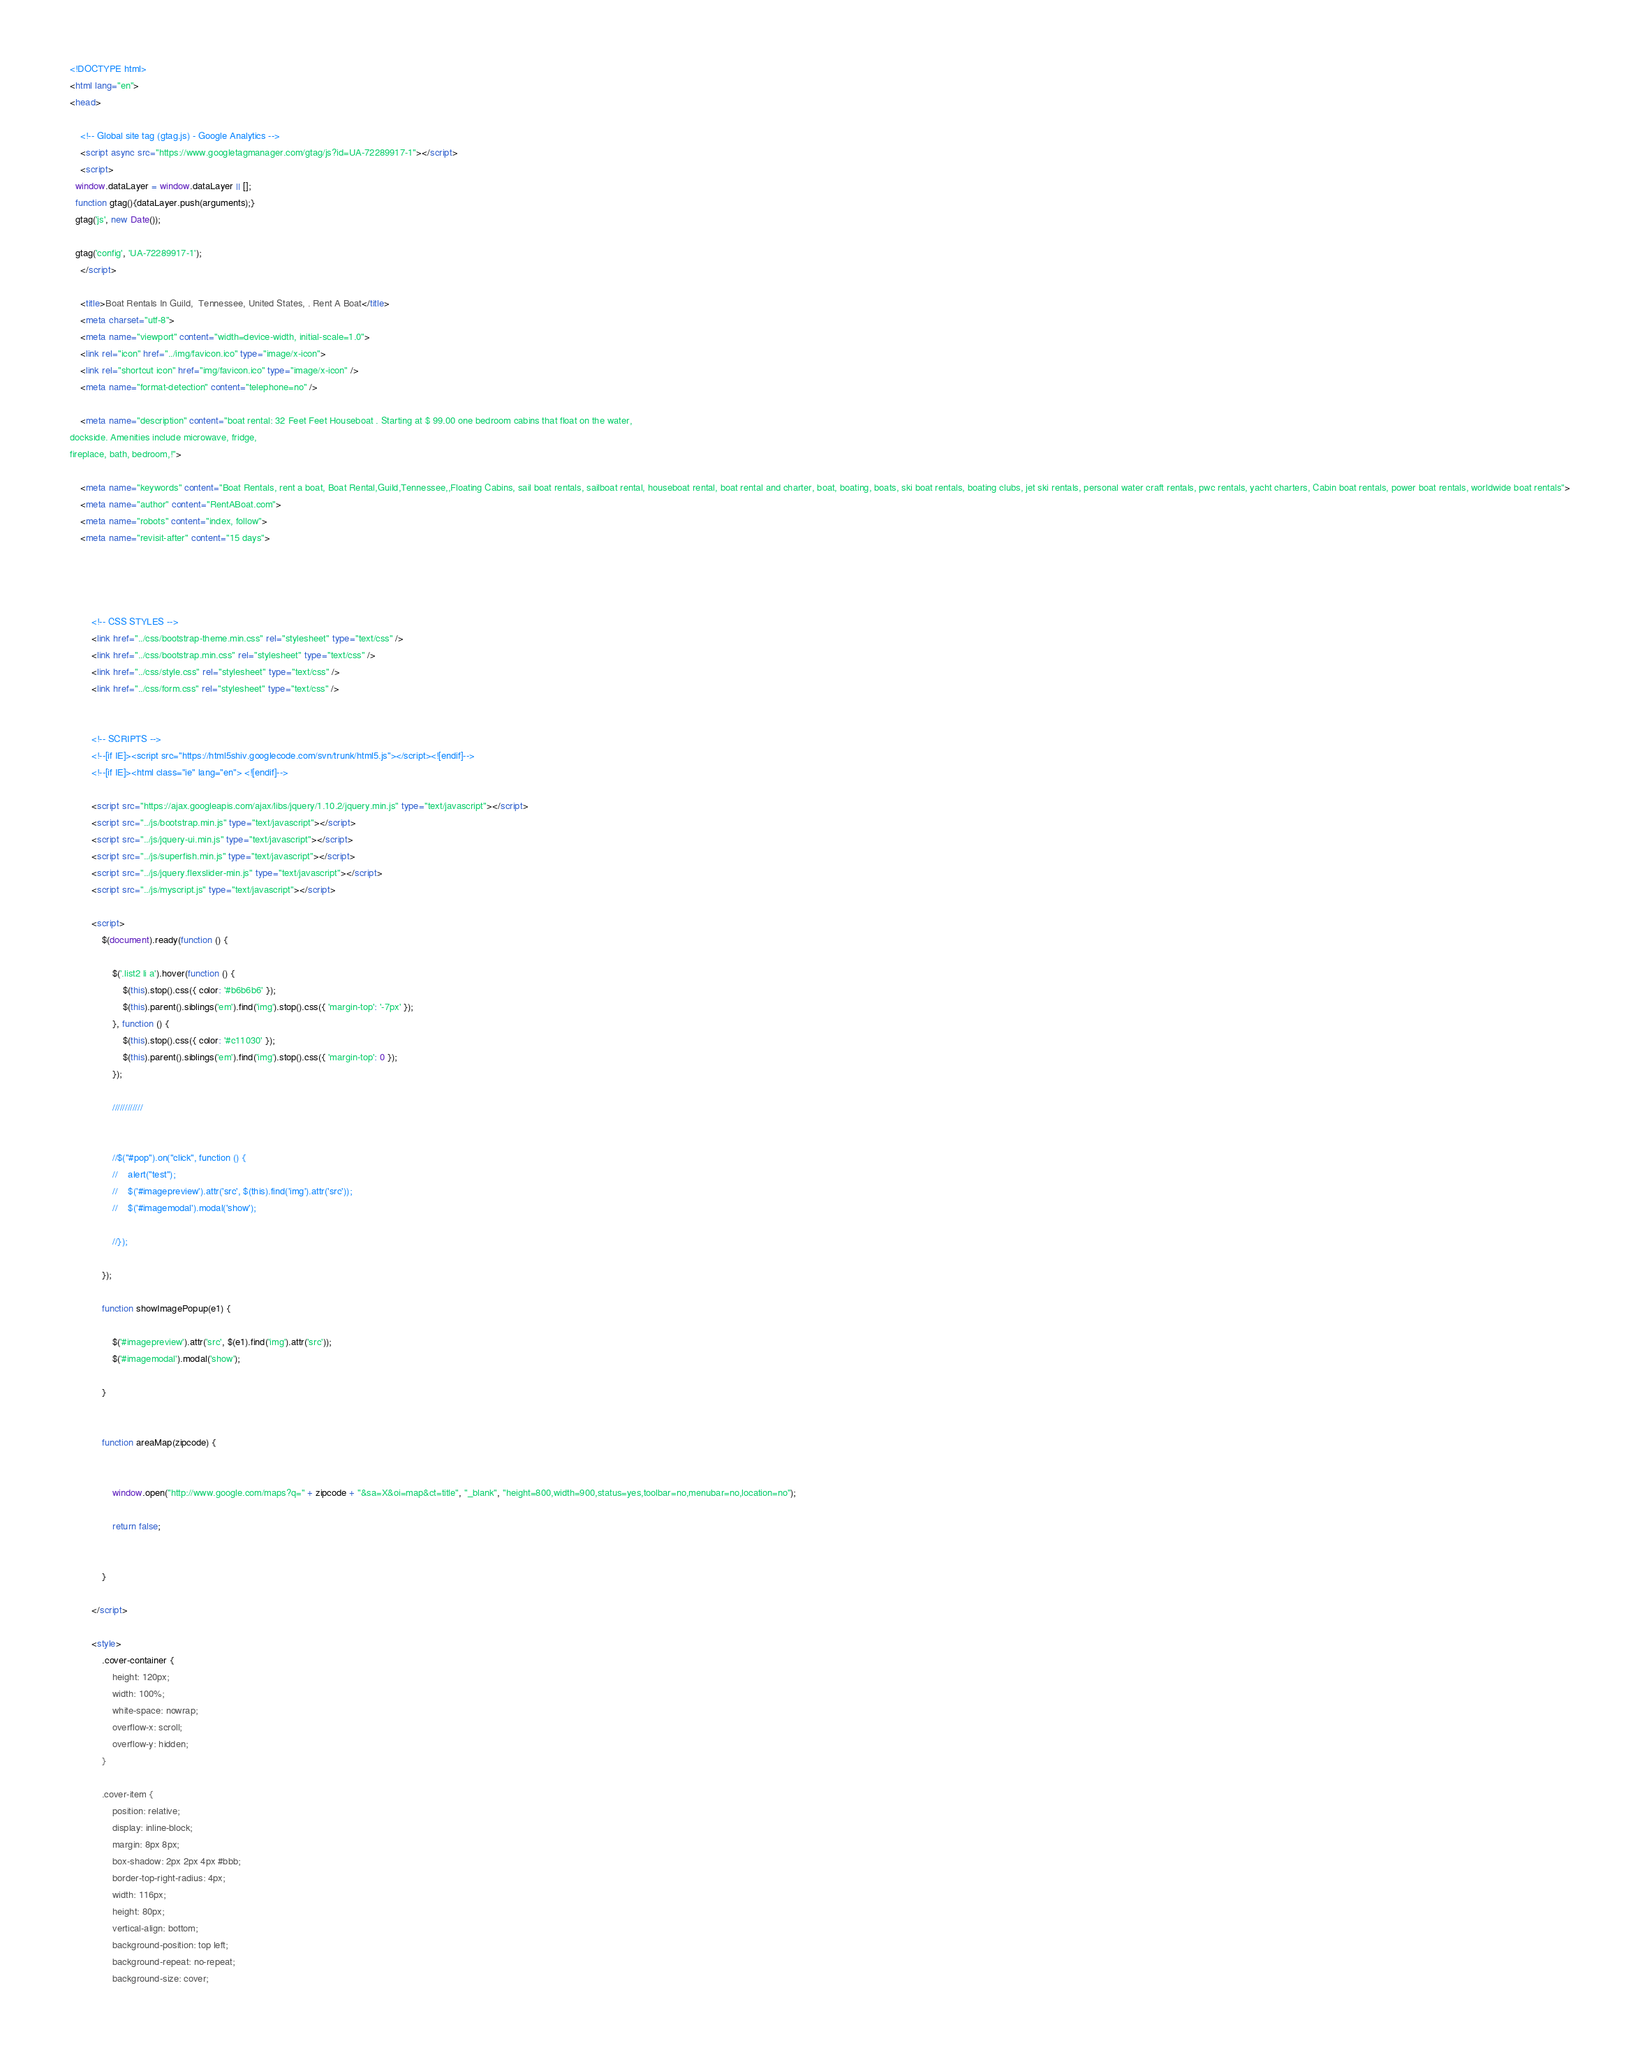<code> <loc_0><loc_0><loc_500><loc_500><_HTML_><!DOCTYPE html>
<html lang="en">
<head>

    <!-- Global site tag (gtag.js) - Google Analytics -->
    <script async src="https://www.googletagmanager.com/gtag/js?id=UA-72289917-1"></script>
    <script>
  window.dataLayer = window.dataLayer || [];
  function gtag(){dataLayer.push(arguments);}
  gtag('js', new Date());

  gtag('config', 'UA-72289917-1');
    </script>

    <title>Boat Rentals In Guild,  Tennessee, United States, . Rent A Boat</title>
    <meta charset="utf-8">
    <meta name="viewport" content="width=device-width, initial-scale=1.0">
    <link rel="icon" href="../img/favicon.ico" type="image/x-icon">
    <link rel="shortcut icon" href="img/favicon.ico" type="image/x-icon" />
    <meta name="format-detection" content="telephone=no" />
    
    <meta name="description" content="boat rental: 32 Feet Feet Houseboat . Starting at $ 99.00 one bedroom cabins that float on the water, 
dockside. Amenities include microwave, fridge, 
fireplace, bath, bedroom,!">
 
    <meta name="keywords" content="Boat Rentals, rent a boat, Boat Rental,Guild,Tennessee,,Floating Cabins, sail boat rentals, sailboat rental, houseboat rental, boat rental and charter, boat, boating, boats, ski boat rentals, boating clubs, jet ski rentals, personal water craft rentals, pwc rentals, yacht charters, Cabin boat rentals, power boat rentals, worldwide boat rentals">
    <meta name="author" content="RentABoat.com">
    <meta name="robots" content="index, follow">
    <meta name="revisit-after" content="15 days">

    


        <!-- CSS STYLES -->
        <link href="../css/bootstrap-theme.min.css" rel="stylesheet" type="text/css" />
        <link href="../css/bootstrap.min.css" rel="stylesheet" type="text/css" />
        <link href="../css/style.css" rel="stylesheet" type="text/css" />
        <link href="../css/form.css" rel="stylesheet" type="text/css" />


        <!-- SCRIPTS -->
        <!--[if IE]><script src="https://html5shiv.googlecode.com/svn/trunk/html5.js"></script><![endif]-->
        <!--[if IE]><html class="ie" lang="en"> <![endif]-->

        <script src="https://ajax.googleapis.com/ajax/libs/jquery/1.10.2/jquery.min.js" type="text/javascript"></script>
        <script src="../js/bootstrap.min.js" type="text/javascript"></script>
        <script src="../js/jquery-ui.min.js" type="text/javascript"></script>
        <script src="../js/superfish.min.js" type="text/javascript"></script>
        <script src="../js/jquery.flexslider-min.js" type="text/javascript"></script>
        <script src="../js/myscript.js" type="text/javascript"></script>

        <script>
            $(document).ready(function () {

                $('.list2 li a').hover(function () {
                    $(this).stop().css({ color: '#b6b6b6' });
                    $(this).parent().siblings('em').find('img').stop().css({ 'margin-top': '-7px' });
                }, function () {
                    $(this).stop().css({ color: '#c11030' });
                    $(this).parent().siblings('em').find('img').stop().css({ 'margin-top': 0 });
                });

                ////////////


                //$("#pop").on("click", function () {
                //    alert("test");
                //    $('#imagepreview').attr('src', $(this).find('img').attr('src'));
                //    $('#imagemodal').modal('show');

                //});

            });

            function showImagePopup(e1) {

                $('#imagepreview').attr('src', $(e1).find('img').attr('src'));
                $('#imagemodal').modal('show');

            }


            function areaMap(zipcode) {


                window.open("http://www.google.com/maps?q=" + zipcode + "&sa=X&oi=map&ct=title", "_blank", "height=800,width=900,status=yes,toolbar=no,menubar=no,location=no");

                return false;


            }

        </script>

        <style>
            .cover-container {
                height: 120px;
                width: 100%;
                white-space: nowrap;
                overflow-x: scroll;
                overflow-y: hidden;
            }

            .cover-item {
                position: relative;
                display: inline-block;
                margin: 8px 8px;
                box-shadow: 2px 2px 4px #bbb;
                border-top-right-radius: 4px;
                width: 116px;
                height: 80px;
                vertical-align: bottom;
                background-position: top left;
                background-repeat: no-repeat;
                background-size: cover;</code> 